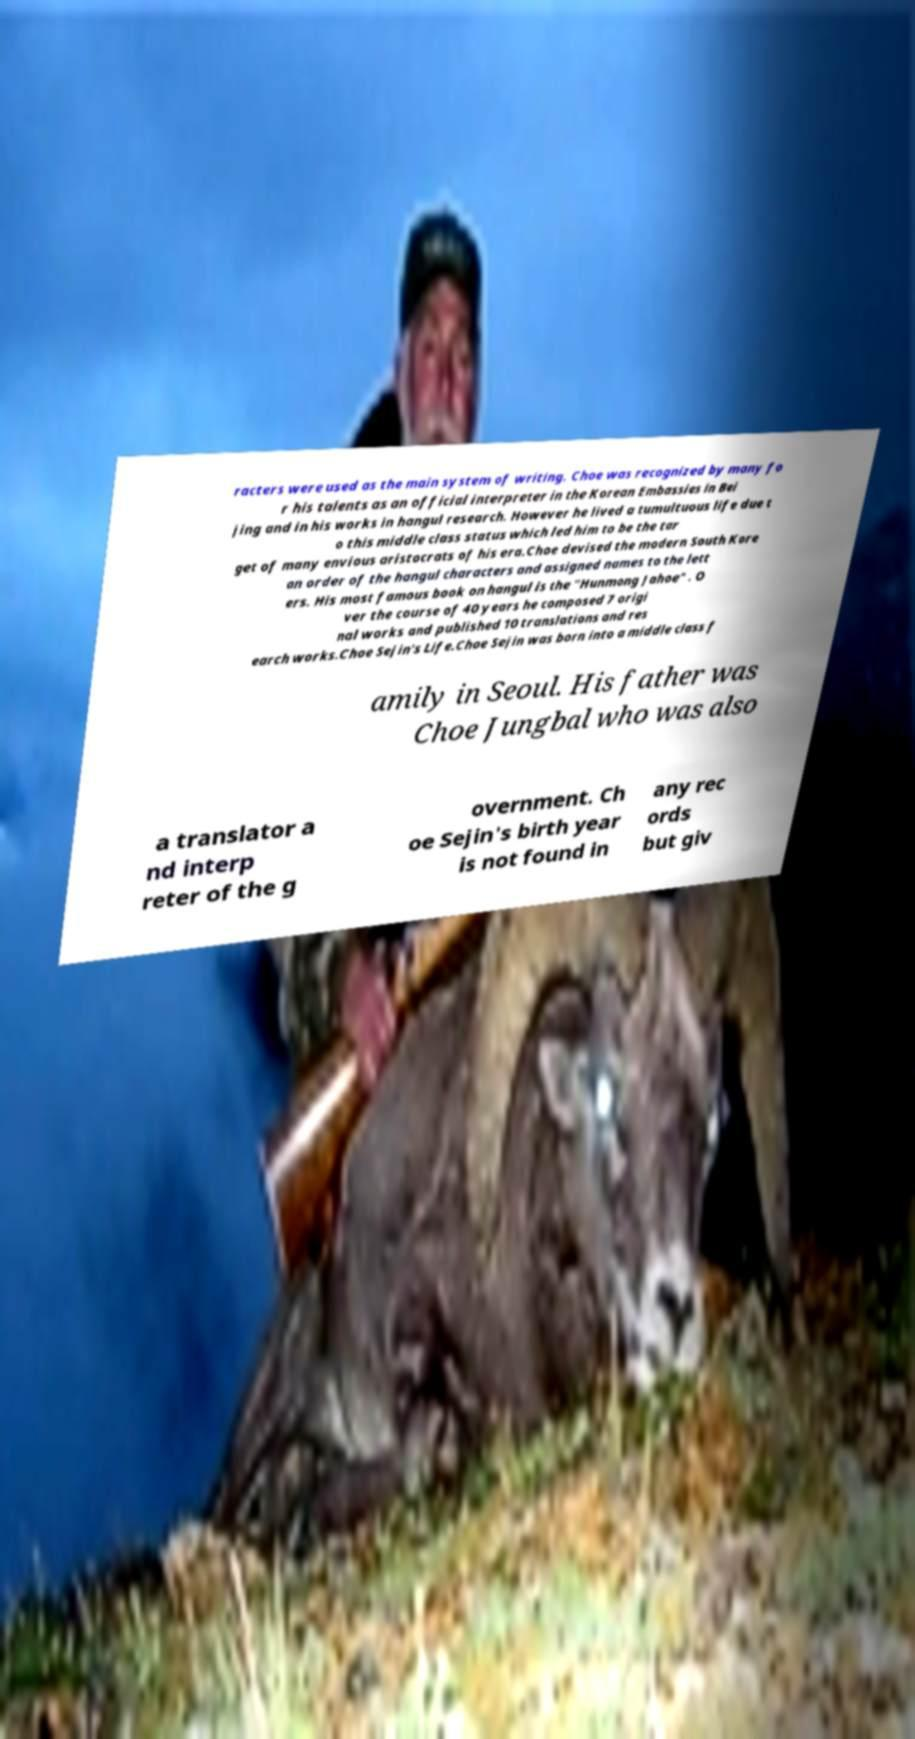Could you assist in decoding the text presented in this image and type it out clearly? racters were used as the main system of writing. Choe was recognized by many fo r his talents as an official interpreter in the Korean Embassies in Bei jing and in his works in hangul research. However he lived a tumultuous life due t o this middle class status which led him to be the tar get of many envious aristocrats of his era.Choe devised the modern South Kore an order of the hangul characters and assigned names to the lett ers. His most famous book on hangul is the "Hunmong Jahoe" . O ver the course of 40 years he composed 7 origi nal works and published 10 translations and res earch works.Choe Sejin's Life.Choe Sejin was born into a middle class f amily in Seoul. His father was Choe Jungbal who was also a translator a nd interp reter of the g overnment. Ch oe Sejin's birth year is not found in any rec ords but giv 